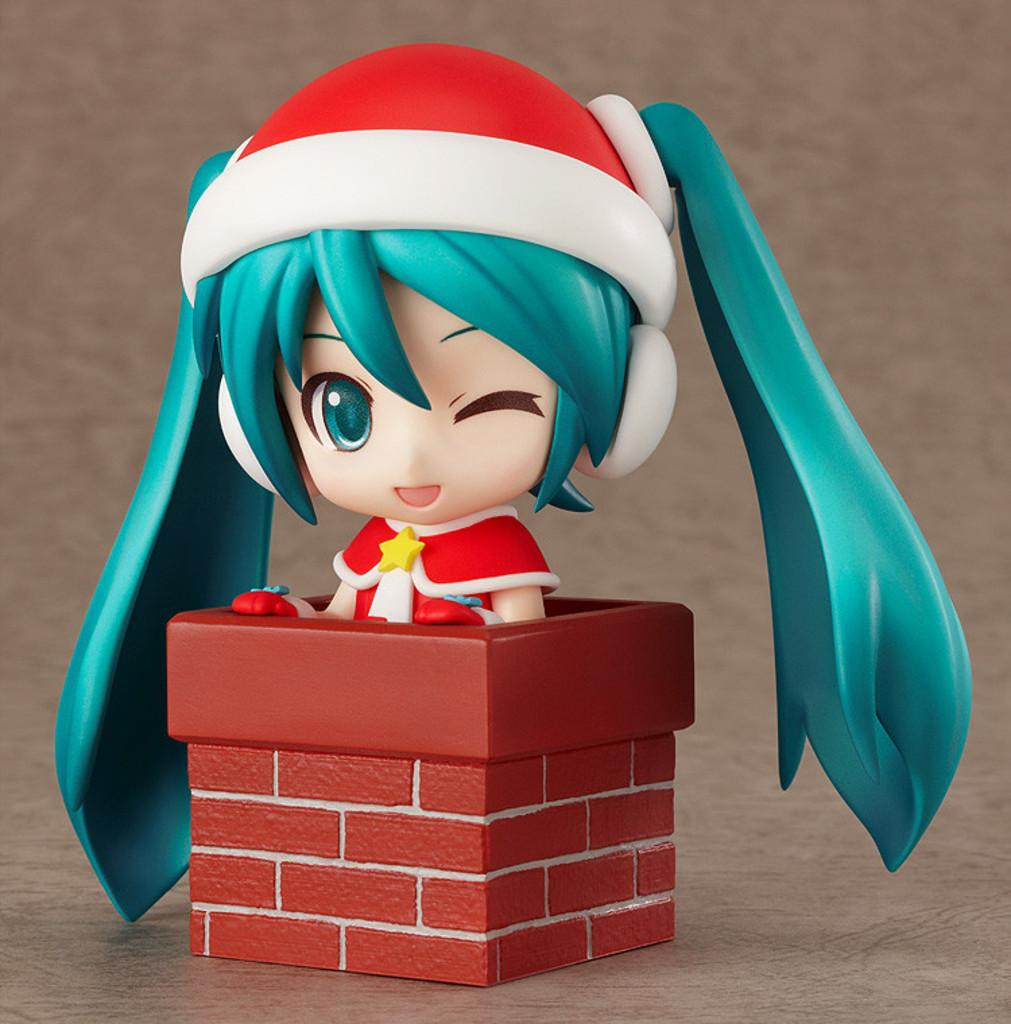What is the main subject of the image? There is a figure in the image. Where is the figure located in the image? The figure is placed on the floor. What is the figure's tendency to eat lunch in the image? There is no information about the figure's lunch habits or tendencies in the image. 